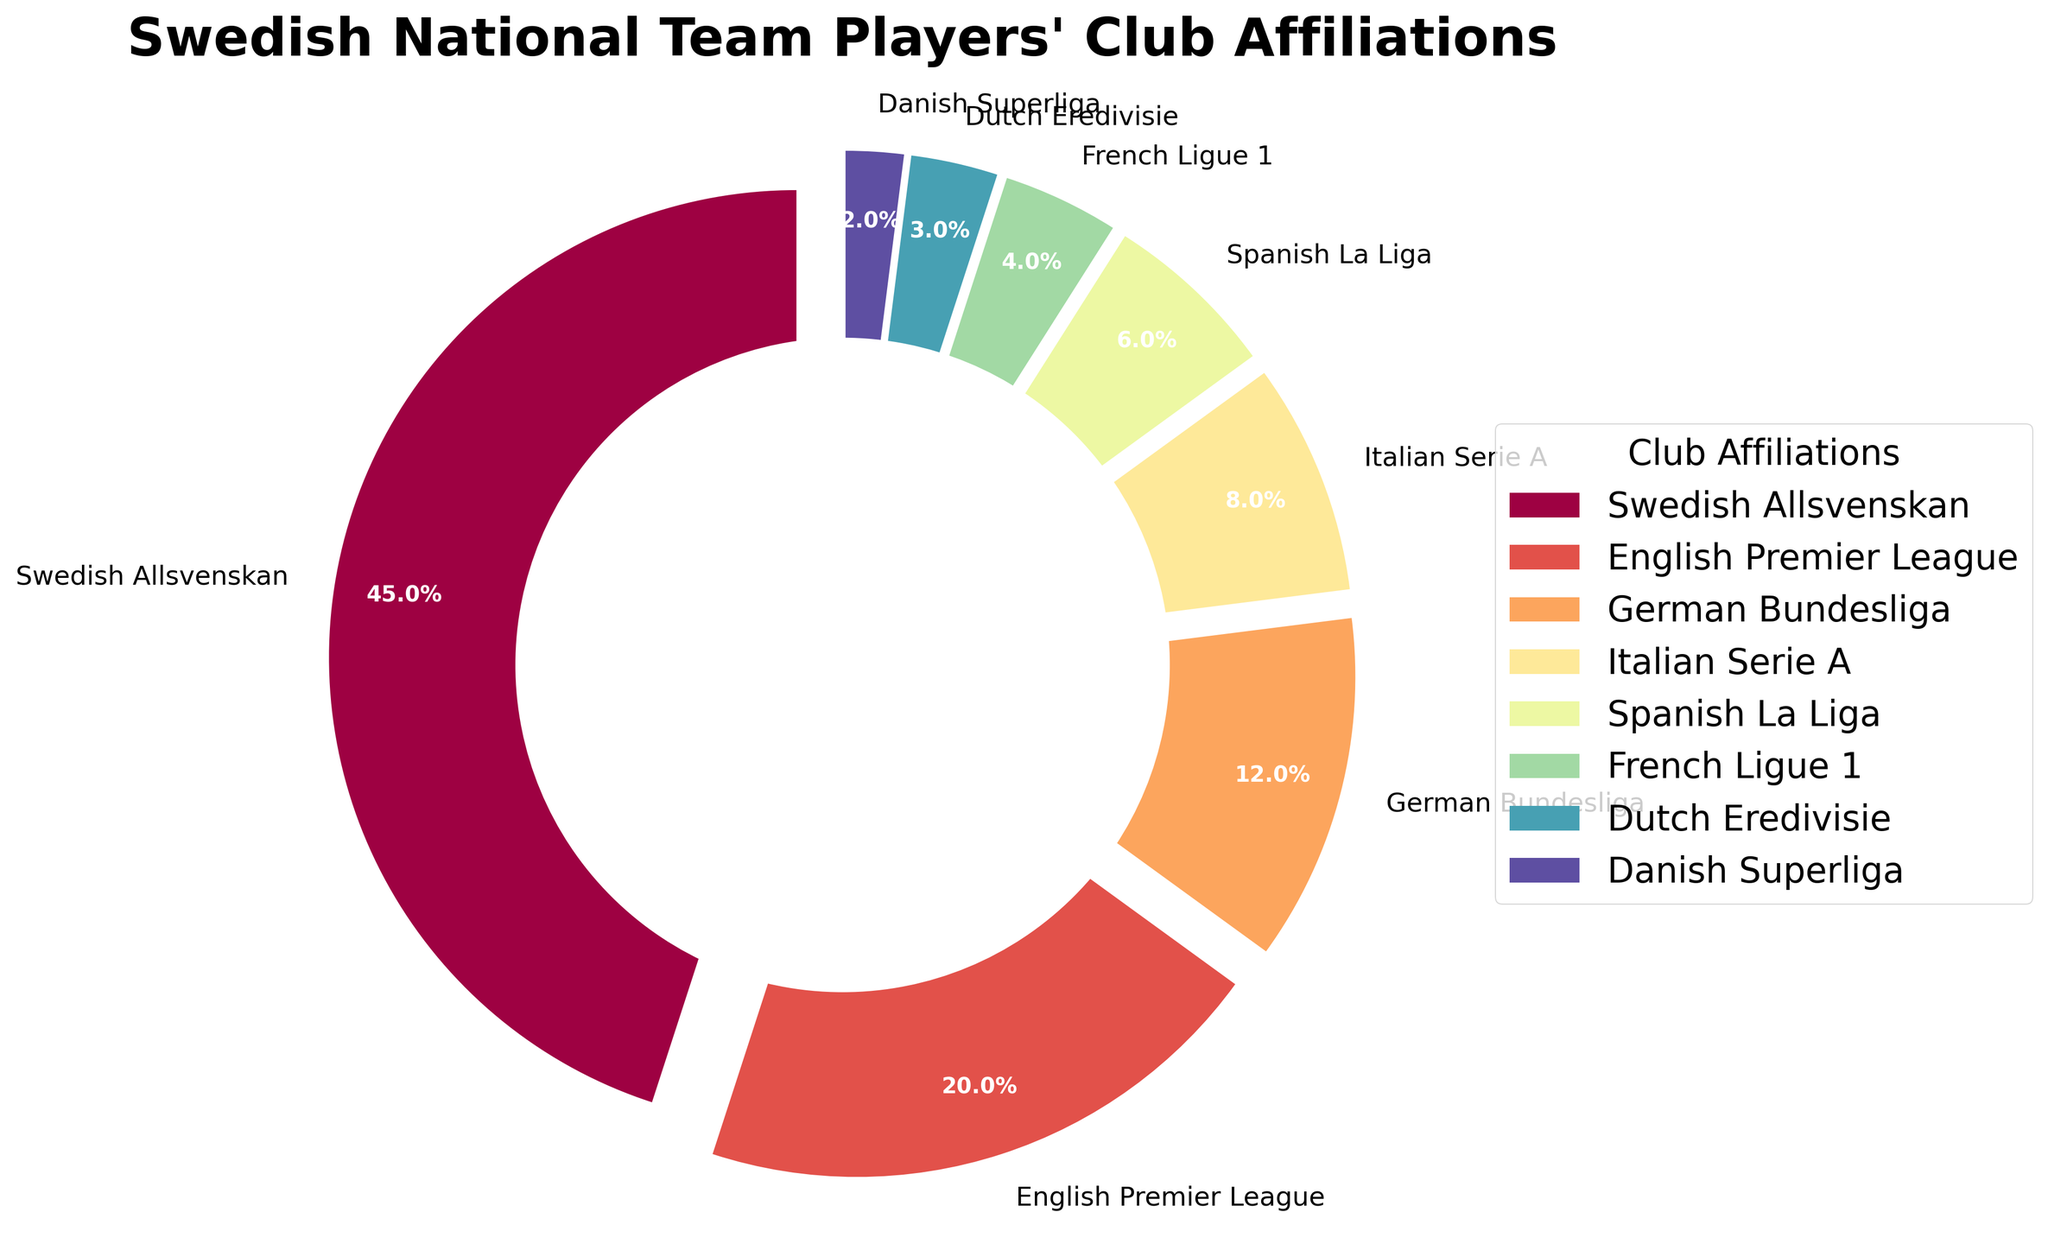Which club affiliation has the highest percentage of Swedish national team players? The club affiliation with the largest slice on the pie chart is Swedish Allsvenskan, marked with a 45% section.
Answer: Swedish Allsvenskan What is the combined percentage of Swedish national team players in the German Bundesliga and Italian Serie A? German Bundesliga has 12% and Italian Serie A has 8%. Adding them together: 12% + 8% = 20%
Answer: 20% Which club affiliation has a larger percentage of players: English Premier League or Spanish La Liga? The English Premier League section is larger at 20%, compared to Spanish La Liga at 6%.
Answer: English Premier League How much smaller is the percentage of players in Dutch Eredivisie compared to French Ligue 1? The Dutch Eredivisie has 3%, and the French Ligue 1 has 4%. The difference is 4% - 3% = 1%.
Answer: 1% Are there more Swedish national team players in the Danish Superliga or the Dutch Eredivisie? The pie chart shows that Dutch Eredivisie has 3%, whereas Danish Superliga has 2%. Therefore, there are more players in the Dutch Eredivisie.
Answer: Dutch Eredivisie What percentage of Swedish national team players are in clubs outside of Sweden? Summing up the percentages of all the international clubs: 20% (EPL) + 12% (Bundesliga) + 8% (Serie A) + 6% (La Liga) + 4% (Ligue 1) + 3% (Eredivisie) + 2% (Superliga) = 55%
Answer: 55% By how much does the percentage of players in the English Premier League exceed those in the Italian Serie A? The English Premier League has 20%, while the Italian Serie A has 8%. The difference is 20% - 8% = 12%.
Answer: 12% What is the average percentage of players in the German Bundesliga, Italian Serie A, and Spanish La Liga? The German Bundesliga has 12%, Italian Serie A has 8%, and Spanish La Liga has 6%. The average is calculated as (12% + 8% + 6%) / 3 = 8.67%.
Answer: 8.67% Which two club affiliations together make up exactly 10% of the Swedish national team players? The French Ligue 1 has 4% and Danish Superliga has 2%. Adding these to Dutch Eredivisie with 3%, we get 4% + 3% + 3% = 10%.
Answer: French Ligue 1 and Dutch Eredivisie Which club affiliation represents a smaller percentage, Spanish La Liga or French Ligue 1? The percentage for Spanish La Liga is 6%, while for French Ligue 1 it is 4%. Therefore, French Ligue 1 represents a smaller percentage.
Answer: French Ligue 1 